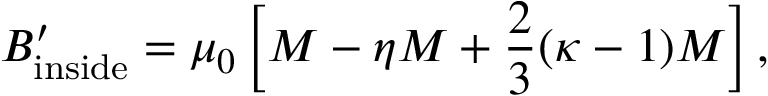<formula> <loc_0><loc_0><loc_500><loc_500>B _ { i n s i d e } ^ { \prime } = \mu _ { 0 } \left [ M - \eta M + { \frac { 2 } { 3 } } ( \kappa - 1 ) M \right ] ,</formula> 